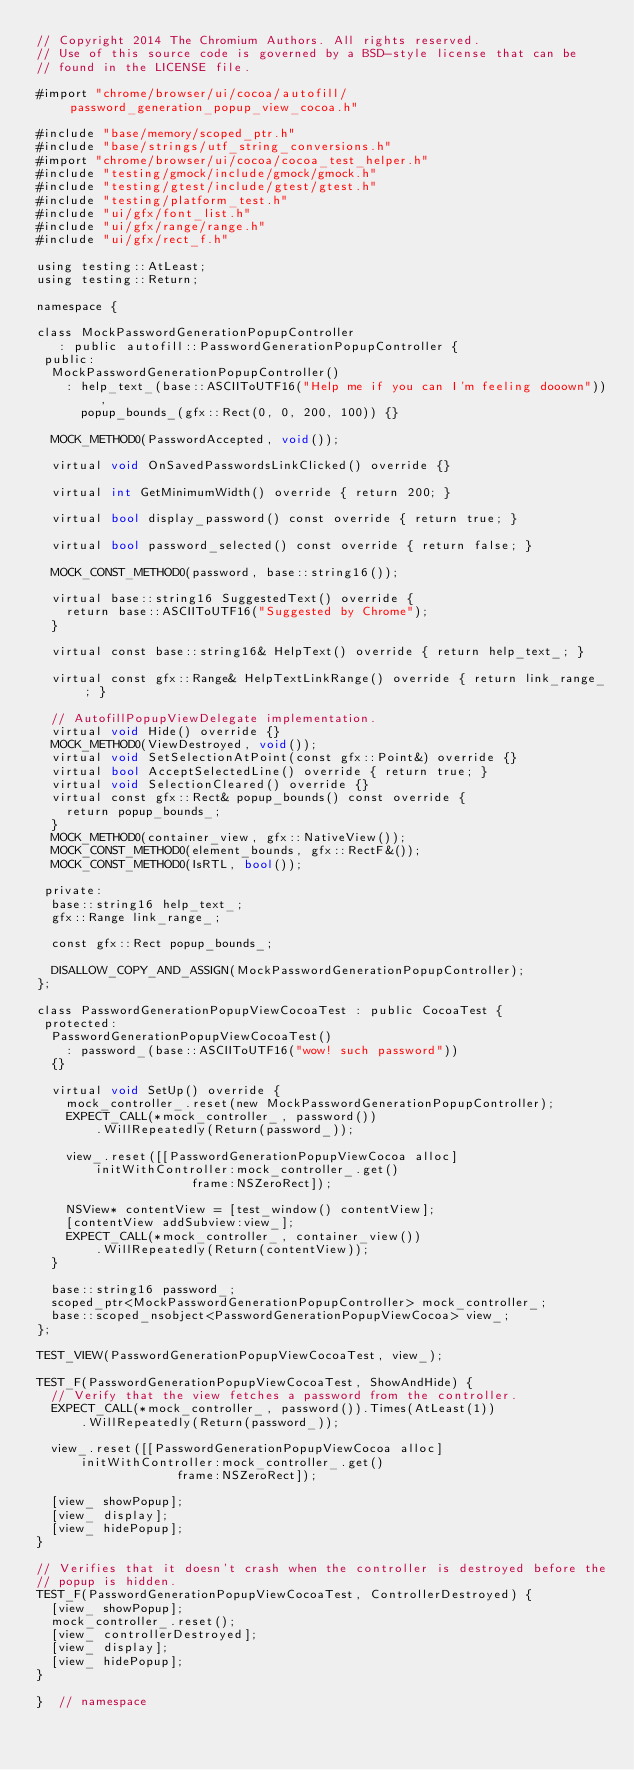<code> <loc_0><loc_0><loc_500><loc_500><_ObjectiveC_>// Copyright 2014 The Chromium Authors. All rights reserved.
// Use of this source code is governed by a BSD-style license that can be
// found in the LICENSE file.

#import "chrome/browser/ui/cocoa/autofill/password_generation_popup_view_cocoa.h"

#include "base/memory/scoped_ptr.h"
#include "base/strings/utf_string_conversions.h"
#import "chrome/browser/ui/cocoa/cocoa_test_helper.h"
#include "testing/gmock/include/gmock/gmock.h"
#include "testing/gtest/include/gtest/gtest.h"
#include "testing/platform_test.h"
#include "ui/gfx/font_list.h"
#include "ui/gfx/range/range.h"
#include "ui/gfx/rect_f.h"

using testing::AtLeast;
using testing::Return;

namespace {

class MockPasswordGenerationPopupController
   : public autofill::PasswordGenerationPopupController {
 public:
  MockPasswordGenerationPopupController()
    : help_text_(base::ASCIIToUTF16("Help me if you can I'm feeling dooown")),
      popup_bounds_(gfx::Rect(0, 0, 200, 100)) {}

  MOCK_METHOD0(PasswordAccepted, void());

  virtual void OnSavedPasswordsLinkClicked() override {}

  virtual int GetMinimumWidth() override { return 200; }

  virtual bool display_password() const override { return true; }

  virtual bool password_selected() const override { return false; }

  MOCK_CONST_METHOD0(password, base::string16());

  virtual base::string16 SuggestedText() override {
    return base::ASCIIToUTF16("Suggested by Chrome");
  }

  virtual const base::string16& HelpText() override { return help_text_; }

  virtual const gfx::Range& HelpTextLinkRange() override { return link_range_; }

  // AutofillPopupViewDelegate implementation.
  virtual void Hide() override {}
  MOCK_METHOD0(ViewDestroyed, void());
  virtual void SetSelectionAtPoint(const gfx::Point&) override {}
  virtual bool AcceptSelectedLine() override { return true; }
  virtual void SelectionCleared() override {}
  virtual const gfx::Rect& popup_bounds() const override {
    return popup_bounds_;
  }
  MOCK_METHOD0(container_view, gfx::NativeView());
  MOCK_CONST_METHOD0(element_bounds, gfx::RectF&());
  MOCK_CONST_METHOD0(IsRTL, bool());

 private:
  base::string16 help_text_;
  gfx::Range link_range_;

  const gfx::Rect popup_bounds_;

  DISALLOW_COPY_AND_ASSIGN(MockPasswordGenerationPopupController);
};

class PasswordGenerationPopupViewCocoaTest : public CocoaTest {
 protected:
  PasswordGenerationPopupViewCocoaTest()
    : password_(base::ASCIIToUTF16("wow! such password"))
  {}

  virtual void SetUp() override {
    mock_controller_.reset(new MockPasswordGenerationPopupController);
    EXPECT_CALL(*mock_controller_, password())
        .WillRepeatedly(Return(password_));

    view_.reset([[PasswordGenerationPopupViewCocoa alloc]
        initWithController:mock_controller_.get()
                     frame:NSZeroRect]);

    NSView* contentView = [test_window() contentView];
    [contentView addSubview:view_];
    EXPECT_CALL(*mock_controller_, container_view())
        .WillRepeatedly(Return(contentView));
  }

  base::string16 password_;
  scoped_ptr<MockPasswordGenerationPopupController> mock_controller_;
  base::scoped_nsobject<PasswordGenerationPopupViewCocoa> view_;
};

TEST_VIEW(PasswordGenerationPopupViewCocoaTest, view_);

TEST_F(PasswordGenerationPopupViewCocoaTest, ShowAndHide) {
  // Verify that the view fetches a password from the controller.
  EXPECT_CALL(*mock_controller_, password()).Times(AtLeast(1))
      .WillRepeatedly(Return(password_));

  view_.reset([[PasswordGenerationPopupViewCocoa alloc]
      initWithController:mock_controller_.get()
                   frame:NSZeroRect]);

  [view_ showPopup];
  [view_ display];
  [view_ hidePopup];
}

// Verifies that it doesn't crash when the controller is destroyed before the
// popup is hidden.
TEST_F(PasswordGenerationPopupViewCocoaTest, ControllerDestroyed) {
  [view_ showPopup];
  mock_controller_.reset();
  [view_ controllerDestroyed];
  [view_ display];
  [view_ hidePopup];
}

}  // namespace
</code> 